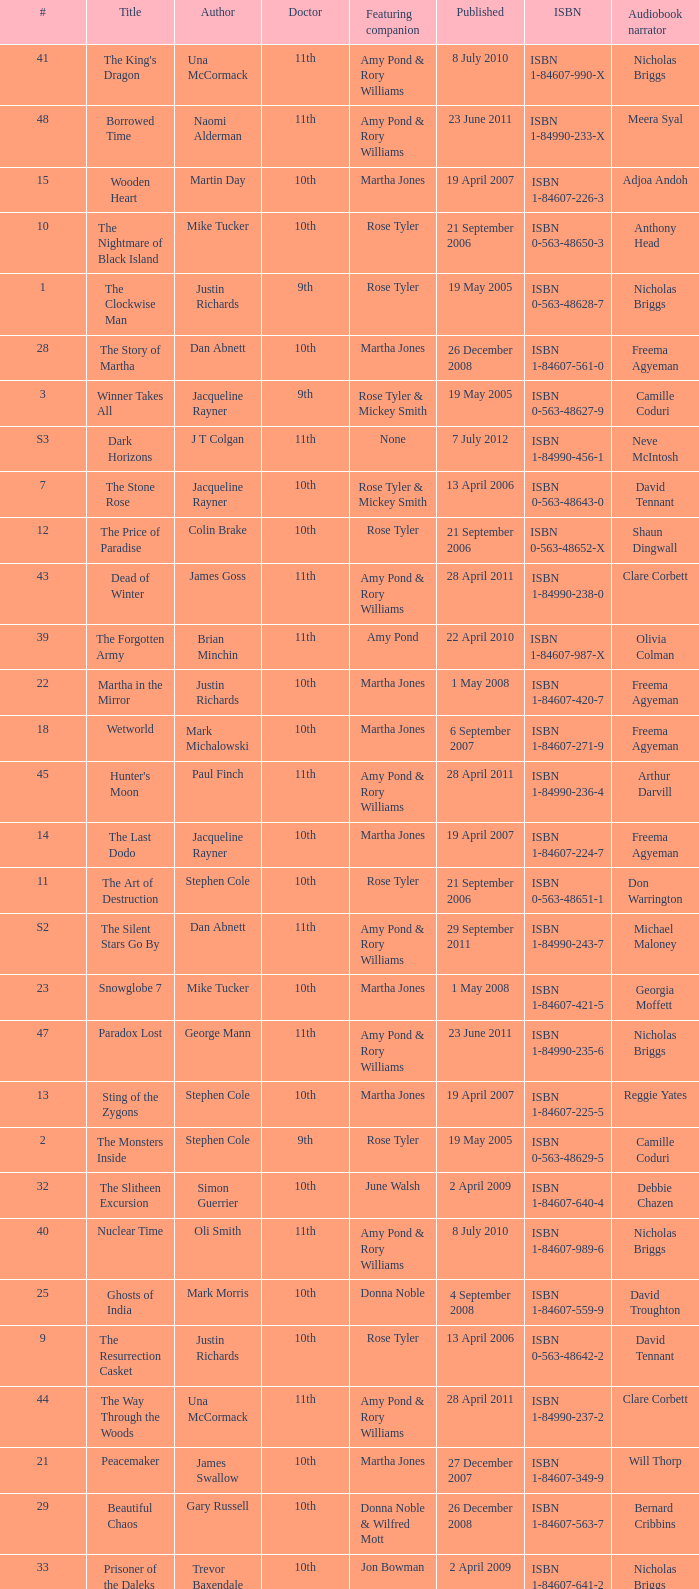What is the title of book number 7? The Stone Rose. 